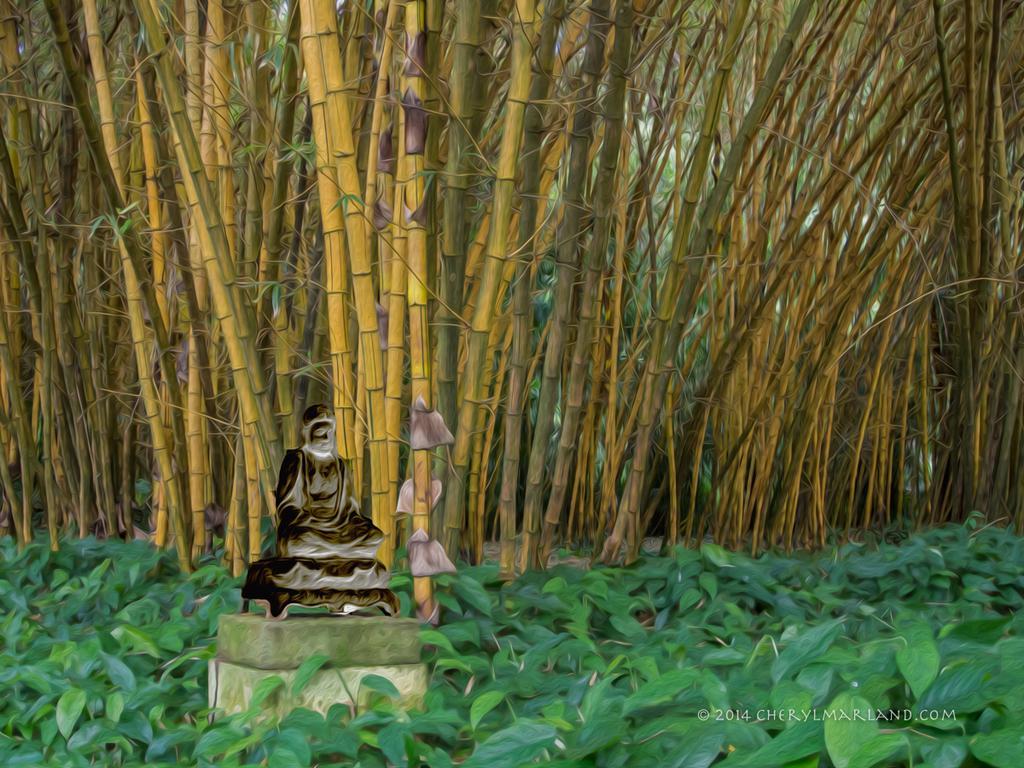Please provide a concise description of this image. In this image we can see an edited picture of a statue placed on the surface. In the background, we can see a group of trees, plants. At the bottom we can see some text. 